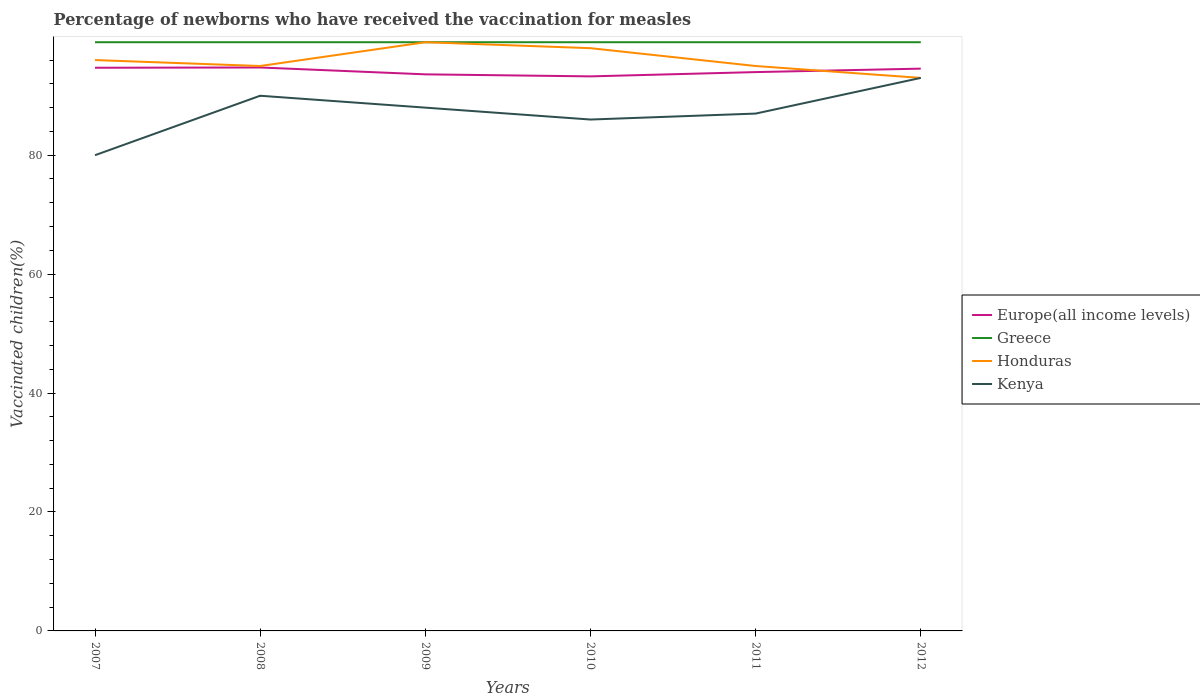How many different coloured lines are there?
Ensure brevity in your answer.  4. Does the line corresponding to Kenya intersect with the line corresponding to Greece?
Your answer should be compact. No. Is the number of lines equal to the number of legend labels?
Provide a short and direct response. Yes. Across all years, what is the maximum percentage of vaccinated children in Honduras?
Your answer should be compact. 93. What is the total percentage of vaccinated children in Honduras in the graph?
Provide a succinct answer. 3. What is the difference between the highest and the second highest percentage of vaccinated children in Greece?
Your response must be concise. 0. What is the difference between the highest and the lowest percentage of vaccinated children in Honduras?
Your answer should be very brief. 2. Is the percentage of vaccinated children in Greece strictly greater than the percentage of vaccinated children in Kenya over the years?
Offer a very short reply. No. How many years are there in the graph?
Provide a short and direct response. 6. Are the values on the major ticks of Y-axis written in scientific E-notation?
Your answer should be compact. No. Does the graph contain any zero values?
Give a very brief answer. No. Does the graph contain grids?
Offer a terse response. No. Where does the legend appear in the graph?
Your answer should be very brief. Center right. How many legend labels are there?
Keep it short and to the point. 4. How are the legend labels stacked?
Ensure brevity in your answer.  Vertical. What is the title of the graph?
Offer a terse response. Percentage of newborns who have received the vaccination for measles. Does "Myanmar" appear as one of the legend labels in the graph?
Make the answer very short. No. What is the label or title of the X-axis?
Your answer should be compact. Years. What is the label or title of the Y-axis?
Your answer should be very brief. Vaccinated children(%). What is the Vaccinated children(%) in Europe(all income levels) in 2007?
Ensure brevity in your answer.  94.71. What is the Vaccinated children(%) in Greece in 2007?
Keep it short and to the point. 99. What is the Vaccinated children(%) of Honduras in 2007?
Your answer should be compact. 96. What is the Vaccinated children(%) of Kenya in 2007?
Provide a succinct answer. 80. What is the Vaccinated children(%) of Europe(all income levels) in 2008?
Your response must be concise. 94.75. What is the Vaccinated children(%) of Greece in 2008?
Your response must be concise. 99. What is the Vaccinated children(%) of Honduras in 2008?
Offer a very short reply. 95. What is the Vaccinated children(%) of Europe(all income levels) in 2009?
Your answer should be very brief. 93.6. What is the Vaccinated children(%) in Honduras in 2009?
Your answer should be compact. 99. What is the Vaccinated children(%) of Europe(all income levels) in 2010?
Provide a short and direct response. 93.26. What is the Vaccinated children(%) in Honduras in 2010?
Ensure brevity in your answer.  98. What is the Vaccinated children(%) in Europe(all income levels) in 2011?
Your answer should be compact. 93.98. What is the Vaccinated children(%) in Honduras in 2011?
Ensure brevity in your answer.  95. What is the Vaccinated children(%) of Europe(all income levels) in 2012?
Your response must be concise. 94.56. What is the Vaccinated children(%) in Greece in 2012?
Your response must be concise. 99. What is the Vaccinated children(%) in Honduras in 2012?
Keep it short and to the point. 93. What is the Vaccinated children(%) of Kenya in 2012?
Give a very brief answer. 93. Across all years, what is the maximum Vaccinated children(%) of Europe(all income levels)?
Keep it short and to the point. 94.75. Across all years, what is the maximum Vaccinated children(%) in Honduras?
Provide a short and direct response. 99. Across all years, what is the maximum Vaccinated children(%) of Kenya?
Provide a succinct answer. 93. Across all years, what is the minimum Vaccinated children(%) in Europe(all income levels)?
Your answer should be compact. 93.26. Across all years, what is the minimum Vaccinated children(%) of Greece?
Your response must be concise. 99. Across all years, what is the minimum Vaccinated children(%) of Honduras?
Your response must be concise. 93. Across all years, what is the minimum Vaccinated children(%) of Kenya?
Make the answer very short. 80. What is the total Vaccinated children(%) in Europe(all income levels) in the graph?
Offer a very short reply. 564.85. What is the total Vaccinated children(%) in Greece in the graph?
Offer a terse response. 594. What is the total Vaccinated children(%) in Honduras in the graph?
Give a very brief answer. 576. What is the total Vaccinated children(%) in Kenya in the graph?
Keep it short and to the point. 524. What is the difference between the Vaccinated children(%) of Europe(all income levels) in 2007 and that in 2008?
Give a very brief answer. -0.04. What is the difference between the Vaccinated children(%) of Greece in 2007 and that in 2008?
Provide a succinct answer. 0. What is the difference between the Vaccinated children(%) in Kenya in 2007 and that in 2008?
Your answer should be very brief. -10. What is the difference between the Vaccinated children(%) in Europe(all income levels) in 2007 and that in 2009?
Offer a very short reply. 1.11. What is the difference between the Vaccinated children(%) of Greece in 2007 and that in 2009?
Your answer should be compact. 0. What is the difference between the Vaccinated children(%) in Honduras in 2007 and that in 2009?
Give a very brief answer. -3. What is the difference between the Vaccinated children(%) of Kenya in 2007 and that in 2009?
Ensure brevity in your answer.  -8. What is the difference between the Vaccinated children(%) in Europe(all income levels) in 2007 and that in 2010?
Provide a short and direct response. 1.45. What is the difference between the Vaccinated children(%) of Europe(all income levels) in 2007 and that in 2011?
Make the answer very short. 0.73. What is the difference between the Vaccinated children(%) of Honduras in 2007 and that in 2011?
Give a very brief answer. 1. What is the difference between the Vaccinated children(%) in Kenya in 2007 and that in 2011?
Offer a very short reply. -7. What is the difference between the Vaccinated children(%) in Europe(all income levels) in 2007 and that in 2012?
Provide a succinct answer. 0.15. What is the difference between the Vaccinated children(%) of Honduras in 2007 and that in 2012?
Offer a terse response. 3. What is the difference between the Vaccinated children(%) in Europe(all income levels) in 2008 and that in 2009?
Give a very brief answer. 1.15. What is the difference between the Vaccinated children(%) in Greece in 2008 and that in 2009?
Keep it short and to the point. 0. What is the difference between the Vaccinated children(%) in Honduras in 2008 and that in 2009?
Give a very brief answer. -4. What is the difference between the Vaccinated children(%) of Europe(all income levels) in 2008 and that in 2010?
Ensure brevity in your answer.  1.49. What is the difference between the Vaccinated children(%) of Europe(all income levels) in 2008 and that in 2011?
Make the answer very short. 0.78. What is the difference between the Vaccinated children(%) in Kenya in 2008 and that in 2011?
Your answer should be compact. 3. What is the difference between the Vaccinated children(%) in Europe(all income levels) in 2008 and that in 2012?
Your answer should be compact. 0.2. What is the difference between the Vaccinated children(%) of Honduras in 2008 and that in 2012?
Your response must be concise. 2. What is the difference between the Vaccinated children(%) of Kenya in 2008 and that in 2012?
Your response must be concise. -3. What is the difference between the Vaccinated children(%) in Europe(all income levels) in 2009 and that in 2010?
Your answer should be very brief. 0.34. What is the difference between the Vaccinated children(%) of Europe(all income levels) in 2009 and that in 2011?
Your response must be concise. -0.38. What is the difference between the Vaccinated children(%) in Greece in 2009 and that in 2011?
Offer a terse response. 0. What is the difference between the Vaccinated children(%) in Honduras in 2009 and that in 2011?
Your answer should be compact. 4. What is the difference between the Vaccinated children(%) of Kenya in 2009 and that in 2011?
Keep it short and to the point. 1. What is the difference between the Vaccinated children(%) of Europe(all income levels) in 2009 and that in 2012?
Provide a short and direct response. -0.96. What is the difference between the Vaccinated children(%) of Kenya in 2009 and that in 2012?
Your response must be concise. -5. What is the difference between the Vaccinated children(%) in Europe(all income levels) in 2010 and that in 2011?
Your answer should be compact. -0.72. What is the difference between the Vaccinated children(%) in Greece in 2010 and that in 2011?
Provide a short and direct response. 0. What is the difference between the Vaccinated children(%) in Europe(all income levels) in 2010 and that in 2012?
Your response must be concise. -1.3. What is the difference between the Vaccinated children(%) of Europe(all income levels) in 2011 and that in 2012?
Make the answer very short. -0.58. What is the difference between the Vaccinated children(%) in Greece in 2011 and that in 2012?
Provide a succinct answer. 0. What is the difference between the Vaccinated children(%) in Europe(all income levels) in 2007 and the Vaccinated children(%) in Greece in 2008?
Your answer should be very brief. -4.29. What is the difference between the Vaccinated children(%) in Europe(all income levels) in 2007 and the Vaccinated children(%) in Honduras in 2008?
Offer a very short reply. -0.29. What is the difference between the Vaccinated children(%) of Europe(all income levels) in 2007 and the Vaccinated children(%) of Kenya in 2008?
Provide a succinct answer. 4.71. What is the difference between the Vaccinated children(%) of Greece in 2007 and the Vaccinated children(%) of Honduras in 2008?
Offer a very short reply. 4. What is the difference between the Vaccinated children(%) in Honduras in 2007 and the Vaccinated children(%) in Kenya in 2008?
Your answer should be compact. 6. What is the difference between the Vaccinated children(%) of Europe(all income levels) in 2007 and the Vaccinated children(%) of Greece in 2009?
Your response must be concise. -4.29. What is the difference between the Vaccinated children(%) of Europe(all income levels) in 2007 and the Vaccinated children(%) of Honduras in 2009?
Make the answer very short. -4.29. What is the difference between the Vaccinated children(%) of Europe(all income levels) in 2007 and the Vaccinated children(%) of Kenya in 2009?
Ensure brevity in your answer.  6.71. What is the difference between the Vaccinated children(%) in Greece in 2007 and the Vaccinated children(%) in Kenya in 2009?
Keep it short and to the point. 11. What is the difference between the Vaccinated children(%) of Europe(all income levels) in 2007 and the Vaccinated children(%) of Greece in 2010?
Provide a succinct answer. -4.29. What is the difference between the Vaccinated children(%) of Europe(all income levels) in 2007 and the Vaccinated children(%) of Honduras in 2010?
Give a very brief answer. -3.29. What is the difference between the Vaccinated children(%) in Europe(all income levels) in 2007 and the Vaccinated children(%) in Kenya in 2010?
Your response must be concise. 8.71. What is the difference between the Vaccinated children(%) in Greece in 2007 and the Vaccinated children(%) in Honduras in 2010?
Keep it short and to the point. 1. What is the difference between the Vaccinated children(%) of Europe(all income levels) in 2007 and the Vaccinated children(%) of Greece in 2011?
Give a very brief answer. -4.29. What is the difference between the Vaccinated children(%) in Europe(all income levels) in 2007 and the Vaccinated children(%) in Honduras in 2011?
Keep it short and to the point. -0.29. What is the difference between the Vaccinated children(%) of Europe(all income levels) in 2007 and the Vaccinated children(%) of Kenya in 2011?
Your answer should be very brief. 7.71. What is the difference between the Vaccinated children(%) in Honduras in 2007 and the Vaccinated children(%) in Kenya in 2011?
Make the answer very short. 9. What is the difference between the Vaccinated children(%) of Europe(all income levels) in 2007 and the Vaccinated children(%) of Greece in 2012?
Your response must be concise. -4.29. What is the difference between the Vaccinated children(%) in Europe(all income levels) in 2007 and the Vaccinated children(%) in Honduras in 2012?
Provide a succinct answer. 1.71. What is the difference between the Vaccinated children(%) in Europe(all income levels) in 2007 and the Vaccinated children(%) in Kenya in 2012?
Provide a short and direct response. 1.71. What is the difference between the Vaccinated children(%) of Honduras in 2007 and the Vaccinated children(%) of Kenya in 2012?
Offer a very short reply. 3. What is the difference between the Vaccinated children(%) in Europe(all income levels) in 2008 and the Vaccinated children(%) in Greece in 2009?
Provide a short and direct response. -4.25. What is the difference between the Vaccinated children(%) of Europe(all income levels) in 2008 and the Vaccinated children(%) of Honduras in 2009?
Provide a succinct answer. -4.25. What is the difference between the Vaccinated children(%) in Europe(all income levels) in 2008 and the Vaccinated children(%) in Kenya in 2009?
Your answer should be very brief. 6.75. What is the difference between the Vaccinated children(%) in Greece in 2008 and the Vaccinated children(%) in Honduras in 2009?
Make the answer very short. 0. What is the difference between the Vaccinated children(%) of Greece in 2008 and the Vaccinated children(%) of Kenya in 2009?
Provide a short and direct response. 11. What is the difference between the Vaccinated children(%) in Honduras in 2008 and the Vaccinated children(%) in Kenya in 2009?
Your answer should be compact. 7. What is the difference between the Vaccinated children(%) in Europe(all income levels) in 2008 and the Vaccinated children(%) in Greece in 2010?
Give a very brief answer. -4.25. What is the difference between the Vaccinated children(%) in Europe(all income levels) in 2008 and the Vaccinated children(%) in Honduras in 2010?
Provide a succinct answer. -3.25. What is the difference between the Vaccinated children(%) of Europe(all income levels) in 2008 and the Vaccinated children(%) of Kenya in 2010?
Your response must be concise. 8.75. What is the difference between the Vaccinated children(%) of Greece in 2008 and the Vaccinated children(%) of Kenya in 2010?
Your response must be concise. 13. What is the difference between the Vaccinated children(%) in Europe(all income levels) in 2008 and the Vaccinated children(%) in Greece in 2011?
Make the answer very short. -4.25. What is the difference between the Vaccinated children(%) in Europe(all income levels) in 2008 and the Vaccinated children(%) in Honduras in 2011?
Your response must be concise. -0.25. What is the difference between the Vaccinated children(%) of Europe(all income levels) in 2008 and the Vaccinated children(%) of Kenya in 2011?
Keep it short and to the point. 7.75. What is the difference between the Vaccinated children(%) of Greece in 2008 and the Vaccinated children(%) of Kenya in 2011?
Provide a short and direct response. 12. What is the difference between the Vaccinated children(%) in Europe(all income levels) in 2008 and the Vaccinated children(%) in Greece in 2012?
Provide a short and direct response. -4.25. What is the difference between the Vaccinated children(%) of Europe(all income levels) in 2008 and the Vaccinated children(%) of Honduras in 2012?
Give a very brief answer. 1.75. What is the difference between the Vaccinated children(%) in Europe(all income levels) in 2008 and the Vaccinated children(%) in Kenya in 2012?
Give a very brief answer. 1.75. What is the difference between the Vaccinated children(%) in Europe(all income levels) in 2009 and the Vaccinated children(%) in Greece in 2010?
Make the answer very short. -5.4. What is the difference between the Vaccinated children(%) of Europe(all income levels) in 2009 and the Vaccinated children(%) of Honduras in 2010?
Ensure brevity in your answer.  -4.4. What is the difference between the Vaccinated children(%) in Europe(all income levels) in 2009 and the Vaccinated children(%) in Kenya in 2010?
Provide a succinct answer. 7.6. What is the difference between the Vaccinated children(%) of Greece in 2009 and the Vaccinated children(%) of Honduras in 2010?
Your answer should be very brief. 1. What is the difference between the Vaccinated children(%) of Greece in 2009 and the Vaccinated children(%) of Kenya in 2010?
Your answer should be compact. 13. What is the difference between the Vaccinated children(%) in Europe(all income levels) in 2009 and the Vaccinated children(%) in Greece in 2011?
Provide a succinct answer. -5.4. What is the difference between the Vaccinated children(%) of Europe(all income levels) in 2009 and the Vaccinated children(%) of Honduras in 2011?
Provide a short and direct response. -1.4. What is the difference between the Vaccinated children(%) of Europe(all income levels) in 2009 and the Vaccinated children(%) of Kenya in 2011?
Offer a very short reply. 6.6. What is the difference between the Vaccinated children(%) in Greece in 2009 and the Vaccinated children(%) in Honduras in 2011?
Give a very brief answer. 4. What is the difference between the Vaccinated children(%) in Europe(all income levels) in 2009 and the Vaccinated children(%) in Greece in 2012?
Your response must be concise. -5.4. What is the difference between the Vaccinated children(%) in Europe(all income levels) in 2009 and the Vaccinated children(%) in Honduras in 2012?
Make the answer very short. 0.6. What is the difference between the Vaccinated children(%) in Europe(all income levels) in 2009 and the Vaccinated children(%) in Kenya in 2012?
Offer a terse response. 0.6. What is the difference between the Vaccinated children(%) in Europe(all income levels) in 2010 and the Vaccinated children(%) in Greece in 2011?
Provide a succinct answer. -5.74. What is the difference between the Vaccinated children(%) in Europe(all income levels) in 2010 and the Vaccinated children(%) in Honduras in 2011?
Your response must be concise. -1.74. What is the difference between the Vaccinated children(%) in Europe(all income levels) in 2010 and the Vaccinated children(%) in Kenya in 2011?
Make the answer very short. 6.26. What is the difference between the Vaccinated children(%) in Greece in 2010 and the Vaccinated children(%) in Honduras in 2011?
Offer a very short reply. 4. What is the difference between the Vaccinated children(%) in Greece in 2010 and the Vaccinated children(%) in Kenya in 2011?
Your answer should be compact. 12. What is the difference between the Vaccinated children(%) in Honduras in 2010 and the Vaccinated children(%) in Kenya in 2011?
Provide a succinct answer. 11. What is the difference between the Vaccinated children(%) in Europe(all income levels) in 2010 and the Vaccinated children(%) in Greece in 2012?
Provide a succinct answer. -5.74. What is the difference between the Vaccinated children(%) in Europe(all income levels) in 2010 and the Vaccinated children(%) in Honduras in 2012?
Offer a terse response. 0.26. What is the difference between the Vaccinated children(%) in Europe(all income levels) in 2010 and the Vaccinated children(%) in Kenya in 2012?
Your answer should be very brief. 0.26. What is the difference between the Vaccinated children(%) of Honduras in 2010 and the Vaccinated children(%) of Kenya in 2012?
Make the answer very short. 5. What is the difference between the Vaccinated children(%) in Europe(all income levels) in 2011 and the Vaccinated children(%) in Greece in 2012?
Provide a short and direct response. -5.02. What is the difference between the Vaccinated children(%) in Europe(all income levels) in 2011 and the Vaccinated children(%) in Honduras in 2012?
Provide a short and direct response. 0.98. What is the difference between the Vaccinated children(%) in Europe(all income levels) in 2011 and the Vaccinated children(%) in Kenya in 2012?
Provide a short and direct response. 0.98. What is the average Vaccinated children(%) in Europe(all income levels) per year?
Your answer should be compact. 94.14. What is the average Vaccinated children(%) of Greece per year?
Give a very brief answer. 99. What is the average Vaccinated children(%) of Honduras per year?
Offer a terse response. 96. What is the average Vaccinated children(%) of Kenya per year?
Your response must be concise. 87.33. In the year 2007, what is the difference between the Vaccinated children(%) of Europe(all income levels) and Vaccinated children(%) of Greece?
Give a very brief answer. -4.29. In the year 2007, what is the difference between the Vaccinated children(%) in Europe(all income levels) and Vaccinated children(%) in Honduras?
Provide a succinct answer. -1.29. In the year 2007, what is the difference between the Vaccinated children(%) of Europe(all income levels) and Vaccinated children(%) of Kenya?
Make the answer very short. 14.71. In the year 2008, what is the difference between the Vaccinated children(%) in Europe(all income levels) and Vaccinated children(%) in Greece?
Give a very brief answer. -4.25. In the year 2008, what is the difference between the Vaccinated children(%) in Europe(all income levels) and Vaccinated children(%) in Honduras?
Give a very brief answer. -0.25. In the year 2008, what is the difference between the Vaccinated children(%) in Europe(all income levels) and Vaccinated children(%) in Kenya?
Your answer should be compact. 4.75. In the year 2008, what is the difference between the Vaccinated children(%) of Honduras and Vaccinated children(%) of Kenya?
Your answer should be very brief. 5. In the year 2009, what is the difference between the Vaccinated children(%) of Europe(all income levels) and Vaccinated children(%) of Greece?
Offer a very short reply. -5.4. In the year 2009, what is the difference between the Vaccinated children(%) in Europe(all income levels) and Vaccinated children(%) in Honduras?
Ensure brevity in your answer.  -5.4. In the year 2009, what is the difference between the Vaccinated children(%) of Europe(all income levels) and Vaccinated children(%) of Kenya?
Give a very brief answer. 5.6. In the year 2010, what is the difference between the Vaccinated children(%) in Europe(all income levels) and Vaccinated children(%) in Greece?
Ensure brevity in your answer.  -5.74. In the year 2010, what is the difference between the Vaccinated children(%) in Europe(all income levels) and Vaccinated children(%) in Honduras?
Provide a short and direct response. -4.74. In the year 2010, what is the difference between the Vaccinated children(%) in Europe(all income levels) and Vaccinated children(%) in Kenya?
Provide a short and direct response. 7.26. In the year 2010, what is the difference between the Vaccinated children(%) in Greece and Vaccinated children(%) in Honduras?
Offer a very short reply. 1. In the year 2010, what is the difference between the Vaccinated children(%) in Greece and Vaccinated children(%) in Kenya?
Provide a succinct answer. 13. In the year 2010, what is the difference between the Vaccinated children(%) in Honduras and Vaccinated children(%) in Kenya?
Keep it short and to the point. 12. In the year 2011, what is the difference between the Vaccinated children(%) of Europe(all income levels) and Vaccinated children(%) of Greece?
Keep it short and to the point. -5.02. In the year 2011, what is the difference between the Vaccinated children(%) of Europe(all income levels) and Vaccinated children(%) of Honduras?
Keep it short and to the point. -1.02. In the year 2011, what is the difference between the Vaccinated children(%) of Europe(all income levels) and Vaccinated children(%) of Kenya?
Ensure brevity in your answer.  6.98. In the year 2011, what is the difference between the Vaccinated children(%) of Greece and Vaccinated children(%) of Honduras?
Offer a terse response. 4. In the year 2011, what is the difference between the Vaccinated children(%) in Greece and Vaccinated children(%) in Kenya?
Ensure brevity in your answer.  12. In the year 2011, what is the difference between the Vaccinated children(%) in Honduras and Vaccinated children(%) in Kenya?
Provide a short and direct response. 8. In the year 2012, what is the difference between the Vaccinated children(%) of Europe(all income levels) and Vaccinated children(%) of Greece?
Give a very brief answer. -4.44. In the year 2012, what is the difference between the Vaccinated children(%) in Europe(all income levels) and Vaccinated children(%) in Honduras?
Your answer should be compact. 1.56. In the year 2012, what is the difference between the Vaccinated children(%) in Europe(all income levels) and Vaccinated children(%) in Kenya?
Keep it short and to the point. 1.56. In the year 2012, what is the difference between the Vaccinated children(%) of Greece and Vaccinated children(%) of Kenya?
Offer a very short reply. 6. In the year 2012, what is the difference between the Vaccinated children(%) of Honduras and Vaccinated children(%) of Kenya?
Give a very brief answer. 0. What is the ratio of the Vaccinated children(%) of Europe(all income levels) in 2007 to that in 2008?
Make the answer very short. 1. What is the ratio of the Vaccinated children(%) in Greece in 2007 to that in 2008?
Make the answer very short. 1. What is the ratio of the Vaccinated children(%) in Honduras in 2007 to that in 2008?
Provide a short and direct response. 1.01. What is the ratio of the Vaccinated children(%) in Europe(all income levels) in 2007 to that in 2009?
Keep it short and to the point. 1.01. What is the ratio of the Vaccinated children(%) in Greece in 2007 to that in 2009?
Keep it short and to the point. 1. What is the ratio of the Vaccinated children(%) of Honduras in 2007 to that in 2009?
Provide a short and direct response. 0.97. What is the ratio of the Vaccinated children(%) in Europe(all income levels) in 2007 to that in 2010?
Provide a succinct answer. 1.02. What is the ratio of the Vaccinated children(%) in Honduras in 2007 to that in 2010?
Keep it short and to the point. 0.98. What is the ratio of the Vaccinated children(%) in Kenya in 2007 to that in 2010?
Provide a succinct answer. 0.93. What is the ratio of the Vaccinated children(%) in Europe(all income levels) in 2007 to that in 2011?
Offer a terse response. 1.01. What is the ratio of the Vaccinated children(%) of Greece in 2007 to that in 2011?
Make the answer very short. 1. What is the ratio of the Vaccinated children(%) of Honduras in 2007 to that in 2011?
Your response must be concise. 1.01. What is the ratio of the Vaccinated children(%) of Kenya in 2007 to that in 2011?
Your response must be concise. 0.92. What is the ratio of the Vaccinated children(%) in Greece in 2007 to that in 2012?
Make the answer very short. 1. What is the ratio of the Vaccinated children(%) of Honduras in 2007 to that in 2012?
Keep it short and to the point. 1.03. What is the ratio of the Vaccinated children(%) in Kenya in 2007 to that in 2012?
Ensure brevity in your answer.  0.86. What is the ratio of the Vaccinated children(%) in Europe(all income levels) in 2008 to that in 2009?
Offer a very short reply. 1.01. What is the ratio of the Vaccinated children(%) of Honduras in 2008 to that in 2009?
Give a very brief answer. 0.96. What is the ratio of the Vaccinated children(%) of Kenya in 2008 to that in 2009?
Your answer should be compact. 1.02. What is the ratio of the Vaccinated children(%) in Greece in 2008 to that in 2010?
Your answer should be very brief. 1. What is the ratio of the Vaccinated children(%) of Honduras in 2008 to that in 2010?
Your response must be concise. 0.97. What is the ratio of the Vaccinated children(%) of Kenya in 2008 to that in 2010?
Provide a short and direct response. 1.05. What is the ratio of the Vaccinated children(%) of Europe(all income levels) in 2008 to that in 2011?
Provide a short and direct response. 1.01. What is the ratio of the Vaccinated children(%) in Greece in 2008 to that in 2011?
Make the answer very short. 1. What is the ratio of the Vaccinated children(%) in Honduras in 2008 to that in 2011?
Your response must be concise. 1. What is the ratio of the Vaccinated children(%) of Kenya in 2008 to that in 2011?
Keep it short and to the point. 1.03. What is the ratio of the Vaccinated children(%) of Honduras in 2008 to that in 2012?
Give a very brief answer. 1.02. What is the ratio of the Vaccinated children(%) of Europe(all income levels) in 2009 to that in 2010?
Give a very brief answer. 1. What is the ratio of the Vaccinated children(%) in Honduras in 2009 to that in 2010?
Your answer should be compact. 1.01. What is the ratio of the Vaccinated children(%) of Kenya in 2009 to that in 2010?
Make the answer very short. 1.02. What is the ratio of the Vaccinated children(%) in Honduras in 2009 to that in 2011?
Your answer should be very brief. 1.04. What is the ratio of the Vaccinated children(%) of Kenya in 2009 to that in 2011?
Your answer should be very brief. 1.01. What is the ratio of the Vaccinated children(%) in Europe(all income levels) in 2009 to that in 2012?
Your answer should be very brief. 0.99. What is the ratio of the Vaccinated children(%) of Honduras in 2009 to that in 2012?
Provide a succinct answer. 1.06. What is the ratio of the Vaccinated children(%) in Kenya in 2009 to that in 2012?
Your response must be concise. 0.95. What is the ratio of the Vaccinated children(%) in Europe(all income levels) in 2010 to that in 2011?
Ensure brevity in your answer.  0.99. What is the ratio of the Vaccinated children(%) in Honduras in 2010 to that in 2011?
Keep it short and to the point. 1.03. What is the ratio of the Vaccinated children(%) of Kenya in 2010 to that in 2011?
Give a very brief answer. 0.99. What is the ratio of the Vaccinated children(%) of Europe(all income levels) in 2010 to that in 2012?
Your answer should be very brief. 0.99. What is the ratio of the Vaccinated children(%) in Honduras in 2010 to that in 2012?
Keep it short and to the point. 1.05. What is the ratio of the Vaccinated children(%) of Kenya in 2010 to that in 2012?
Provide a short and direct response. 0.92. What is the ratio of the Vaccinated children(%) in Europe(all income levels) in 2011 to that in 2012?
Offer a terse response. 0.99. What is the ratio of the Vaccinated children(%) of Honduras in 2011 to that in 2012?
Make the answer very short. 1.02. What is the ratio of the Vaccinated children(%) of Kenya in 2011 to that in 2012?
Your answer should be compact. 0.94. What is the difference between the highest and the second highest Vaccinated children(%) in Europe(all income levels)?
Your answer should be compact. 0.04. What is the difference between the highest and the second highest Vaccinated children(%) of Greece?
Keep it short and to the point. 0. What is the difference between the highest and the second highest Vaccinated children(%) in Honduras?
Provide a succinct answer. 1. What is the difference between the highest and the second highest Vaccinated children(%) in Kenya?
Ensure brevity in your answer.  3. What is the difference between the highest and the lowest Vaccinated children(%) in Europe(all income levels)?
Ensure brevity in your answer.  1.49. What is the difference between the highest and the lowest Vaccinated children(%) in Greece?
Ensure brevity in your answer.  0. 